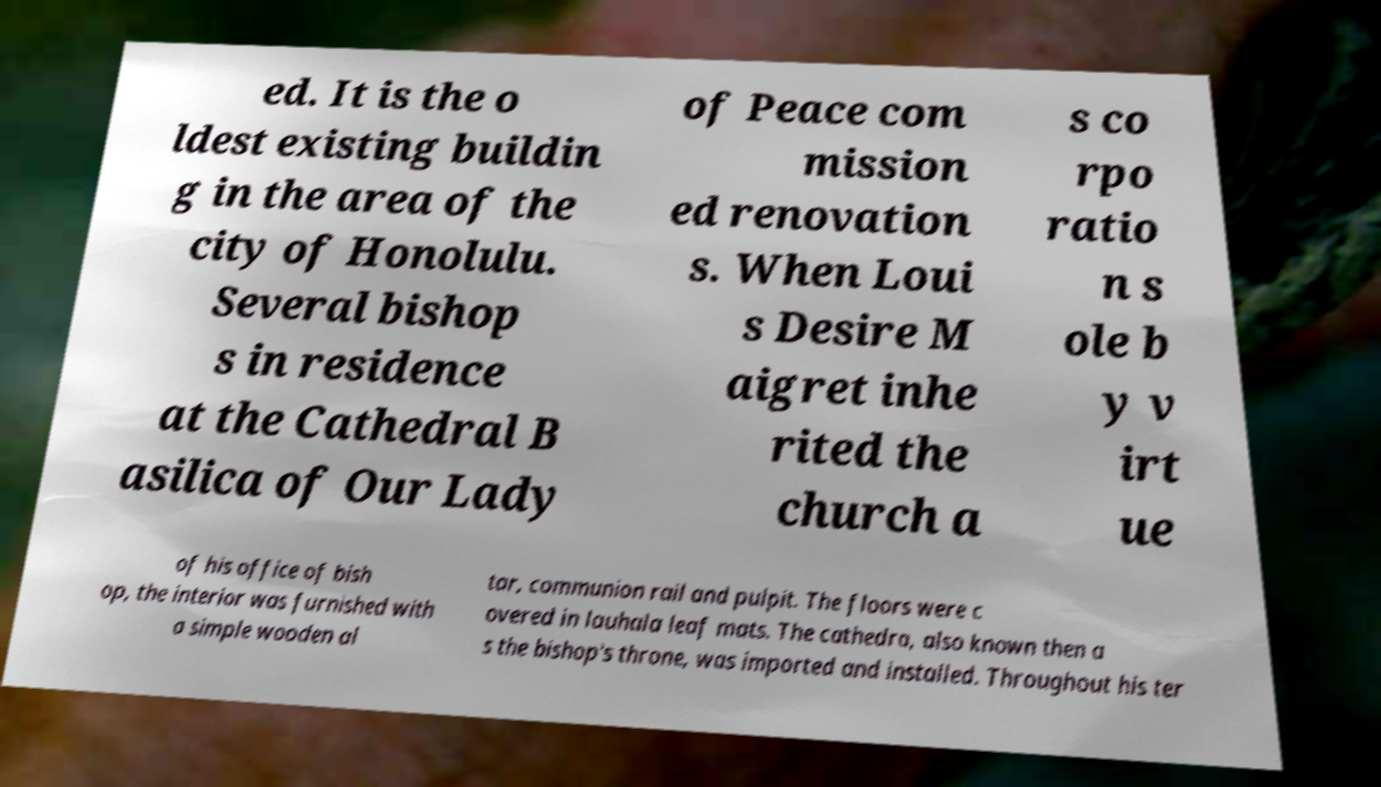Could you extract and type out the text from this image? ed. It is the o ldest existing buildin g in the area of the city of Honolulu. Several bishop s in residence at the Cathedral B asilica of Our Lady of Peace com mission ed renovation s. When Loui s Desire M aigret inhe rited the church a s co rpo ratio n s ole b y v irt ue of his office of bish op, the interior was furnished with a simple wooden al tar, communion rail and pulpit. The floors were c overed in lauhala leaf mats. The cathedra, also known then a s the bishop's throne, was imported and installed. Throughout his ter 